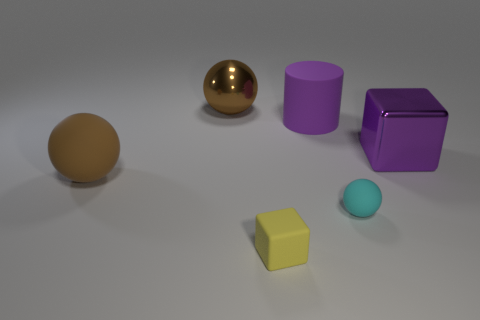There is a rubber sphere to the right of the rubber cube; is it the same size as the cube that is in front of the big purple metallic thing?
Your answer should be very brief. Yes. The large rubber object right of the small yellow matte block is what color?
Keep it short and to the point. Purple. What material is the other large ball that is the same color as the big shiny sphere?
Your response must be concise. Rubber. What number of cubes are the same color as the cylinder?
Your answer should be compact. 1. Do the purple cylinder and the sphere right of the large purple matte cylinder have the same size?
Your answer should be very brief. No. There is a purple cube right of the small thing in front of the small matte object behind the small yellow matte object; how big is it?
Your answer should be very brief. Large. There is a tiny rubber cube; how many yellow rubber objects are left of it?
Your answer should be compact. 0. What is the material of the large block in front of the rubber object behind the brown rubber sphere?
Offer a very short reply. Metal. Do the yellow rubber thing and the cyan object have the same size?
Provide a succinct answer. Yes. How many things are either objects that are left of the yellow block or cubes behind the small rubber cube?
Give a very brief answer. 3. 